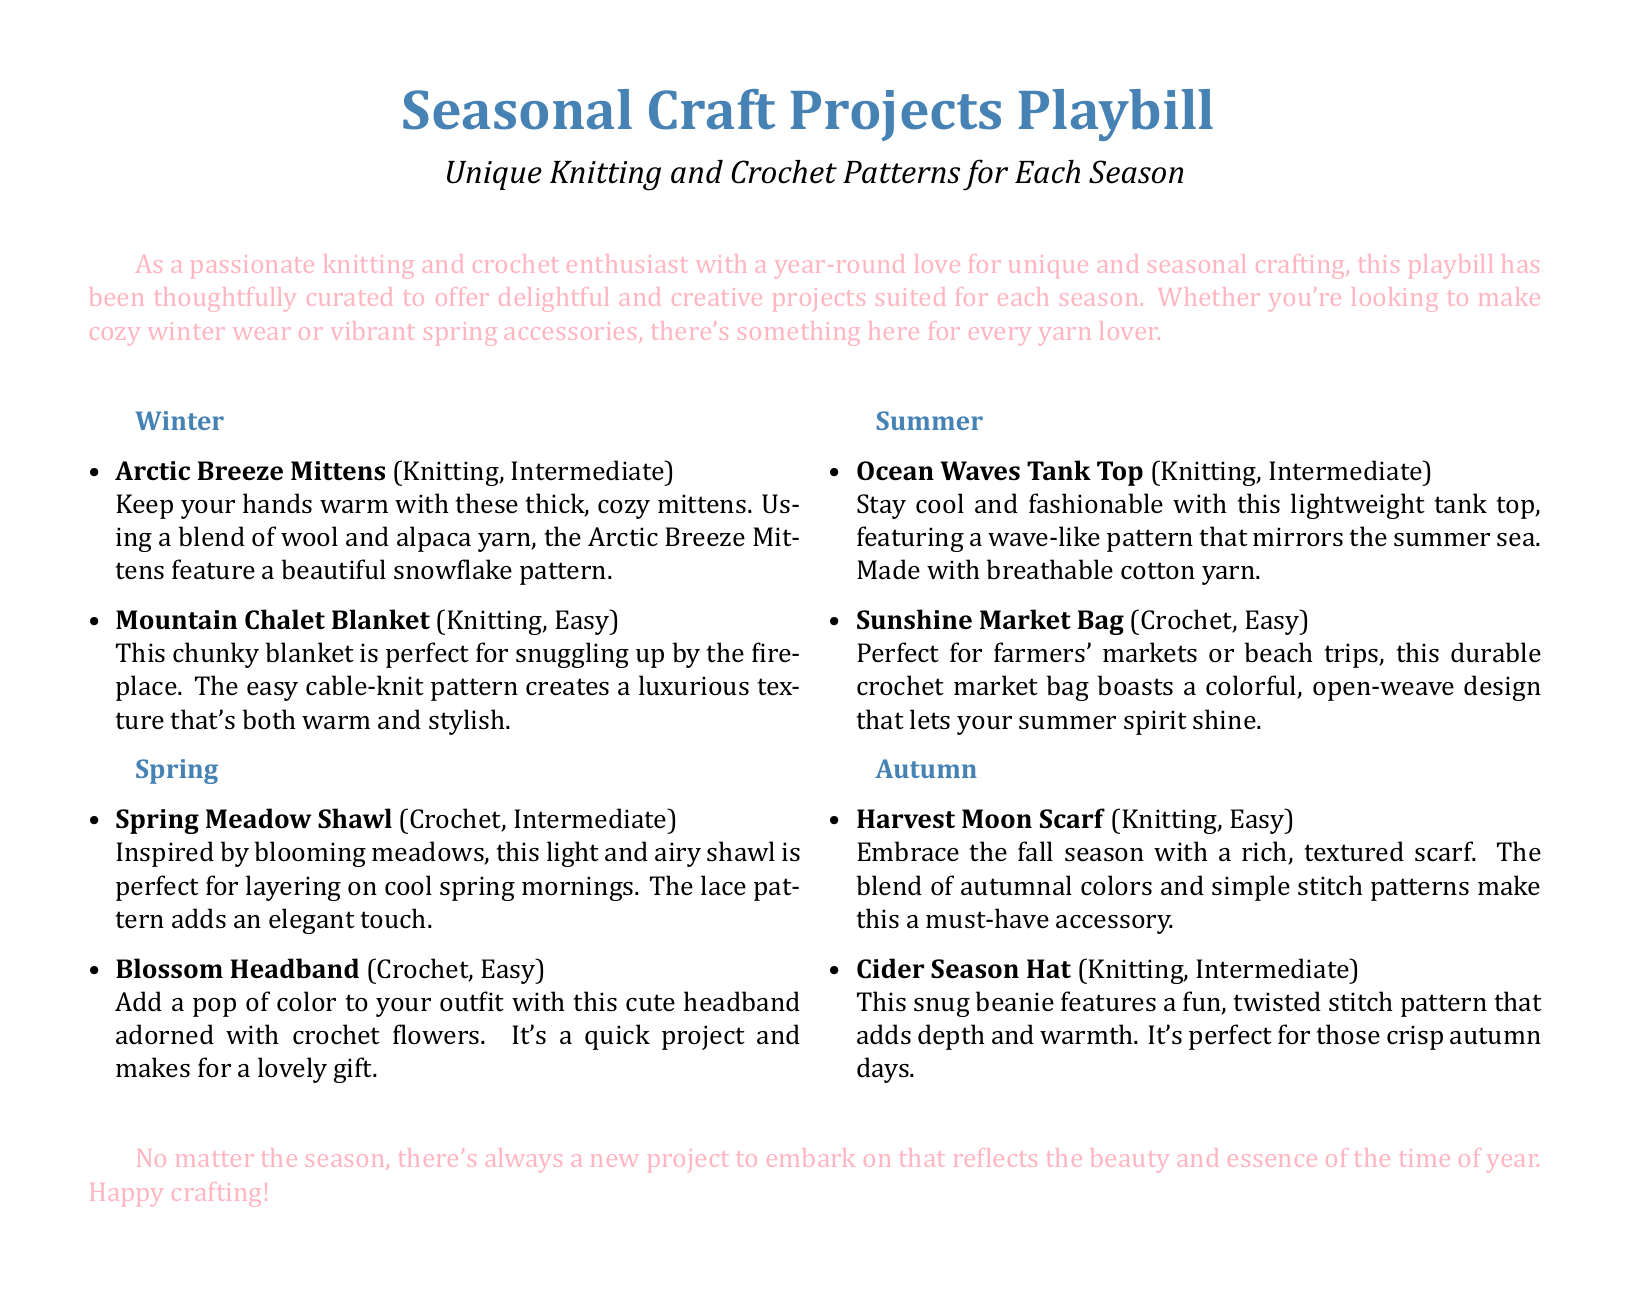What are the Arctic Breeze Mittens? The Arctic Breeze Mittens are a knitting project that is categorized as intermediate. They are designed to keep hands warm and feature a snowflake pattern.
Answer: Arctic Breeze Mittens How many projects are listed under Autumn? The document lists two projects for the Autumn season.
Answer: 2 What type of yarn is used for the Ocean Waves Tank Top? The Ocean Waves Tank Top is made with breathable cotton yarn.
Answer: Cotton yarn What is the skill level for the Blossom Headband? The Blossom Headband is categorized as an easy crochet project.
Answer: Easy What season is the Mountain Chalet Blanket designed for? The Mountain Chalet Blanket is designed for the winter season.
Answer: Winter Which project features a lace pattern? The Spring Meadow Shawl features a lace pattern.
Answer: Spring Meadow Shawl What is the main color theme for the projects in the Autumn section? The main color theme for the projects in the Autumn section is autumnal colors.
Answer: Autumnal colors Which crafting technique is used for the Sunshine Market Bag? The Sunshine Market Bag is made using crochet techniques.
Answer: Crochet What type of projects are included in this Playbill? The Playbill includes unique knitting and crochet patterns for each season.
Answer: Knitting and Crochet Patterns 